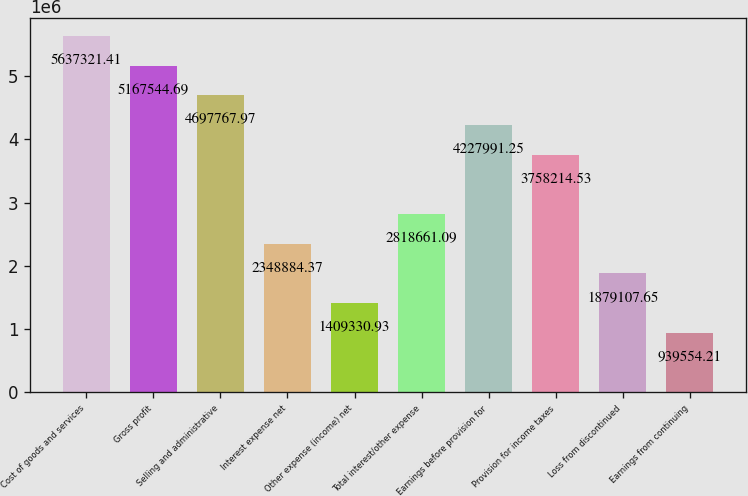<chart> <loc_0><loc_0><loc_500><loc_500><bar_chart><fcel>Cost of goods and services<fcel>Gross profit<fcel>Selling and administrative<fcel>Interest expense net<fcel>Other expense (income) net<fcel>Total interest/other expense<fcel>Earnings before provision for<fcel>Provision for income taxes<fcel>Loss from discontinued<fcel>Earnings from continuing<nl><fcel>5.63732e+06<fcel>5.16754e+06<fcel>4.69777e+06<fcel>2.34888e+06<fcel>1.40933e+06<fcel>2.81866e+06<fcel>4.22799e+06<fcel>3.75821e+06<fcel>1.87911e+06<fcel>939554<nl></chart> 